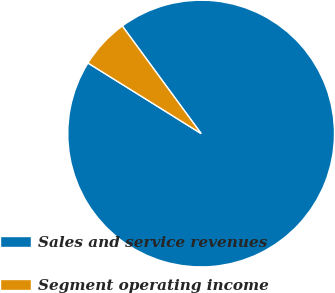Convert chart to OTSL. <chart><loc_0><loc_0><loc_500><loc_500><pie_chart><fcel>Sales and service revenues<fcel>Segment operating income<nl><fcel>93.94%<fcel>6.06%<nl></chart> 